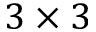<formula> <loc_0><loc_0><loc_500><loc_500>3 \times 3</formula> 